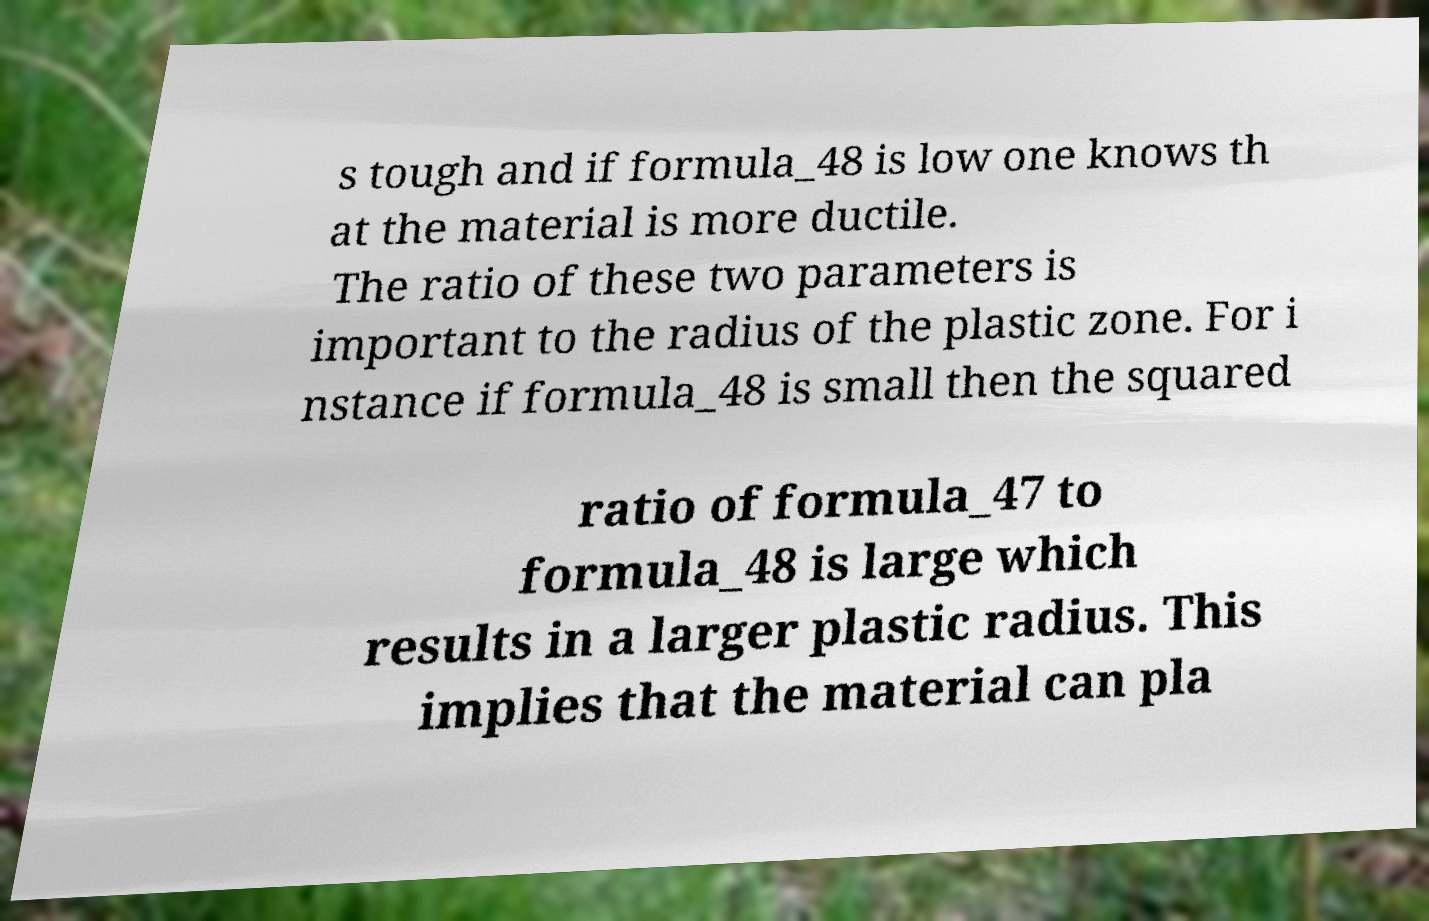Can you read and provide the text displayed in the image?This photo seems to have some interesting text. Can you extract and type it out for me? s tough and if formula_48 is low one knows th at the material is more ductile. The ratio of these two parameters is important to the radius of the plastic zone. For i nstance if formula_48 is small then the squared ratio of formula_47 to formula_48 is large which results in a larger plastic radius. This implies that the material can pla 